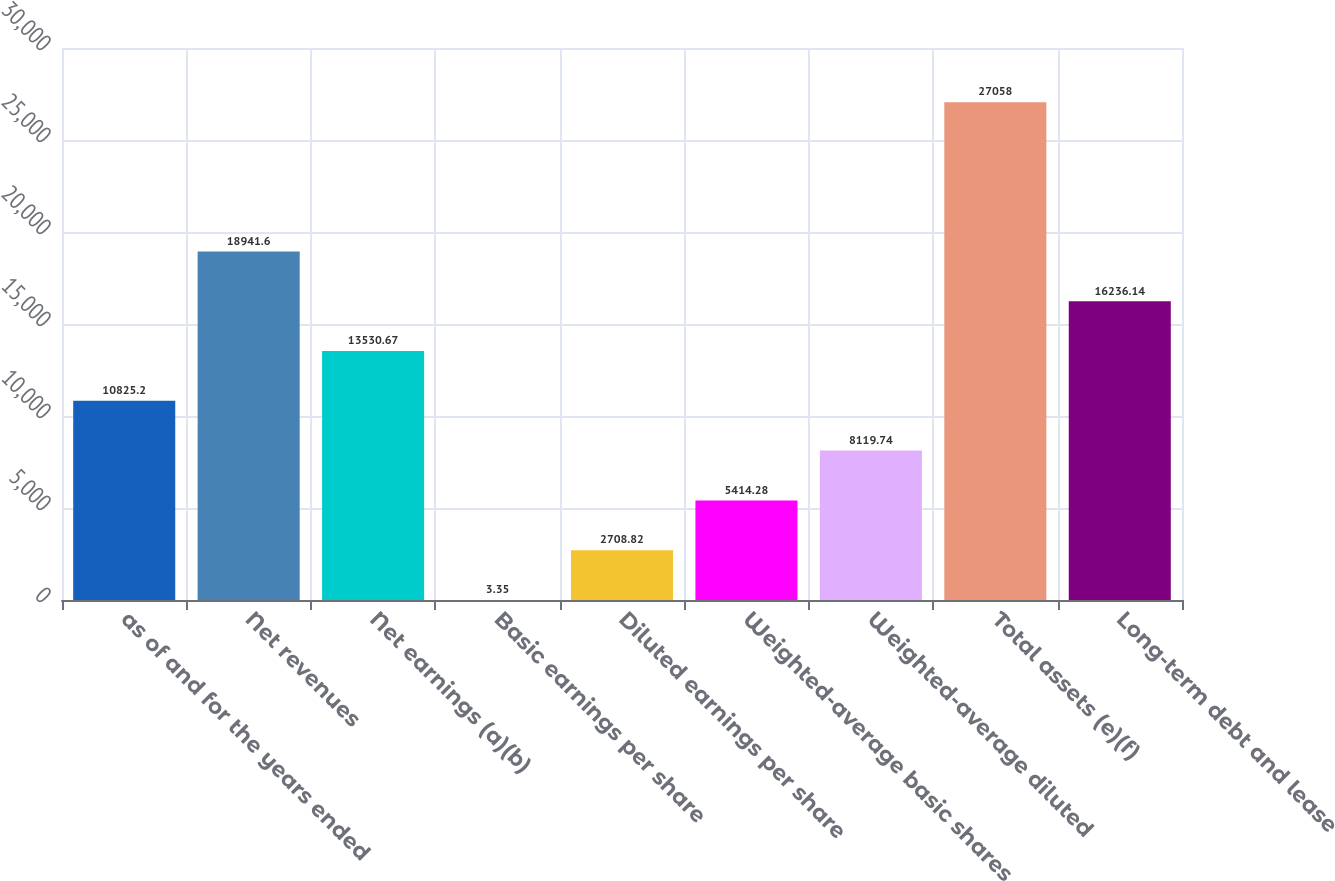Convert chart. <chart><loc_0><loc_0><loc_500><loc_500><bar_chart><fcel>as of and for the years ended<fcel>Net revenues<fcel>Net earnings (a)(b)<fcel>Basic earnings per share<fcel>Diluted earnings per share<fcel>Weighted-average basic shares<fcel>Weighted-average diluted<fcel>Total assets (e)(f)<fcel>Long-term debt and lease<nl><fcel>10825.2<fcel>18941.6<fcel>13530.7<fcel>3.35<fcel>2708.82<fcel>5414.28<fcel>8119.74<fcel>27058<fcel>16236.1<nl></chart> 